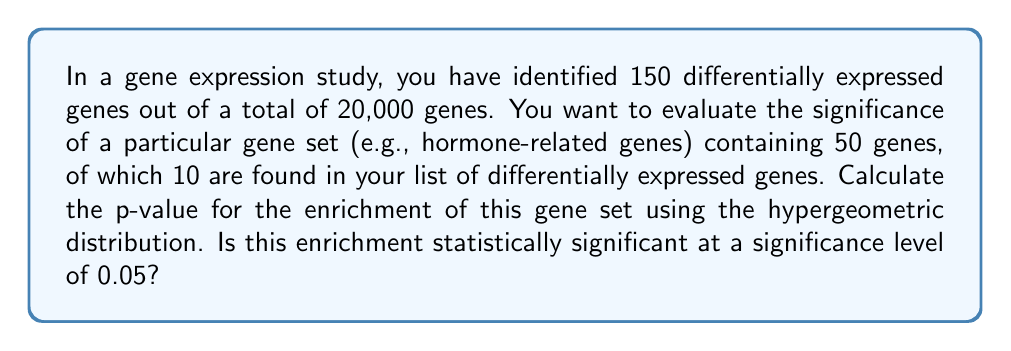Can you solve this math problem? To evaluate the significance of gene set enrichment using the hypergeometric distribution, we need to follow these steps:

1. Define the parameters:
   - $N$: Total number of genes = 20,000
   - $K$: Number of genes in the gene set of interest = 50
   - $n$: Number of differentially expressed genes = 150
   - $k$: Number of differentially expressed genes in the gene set = 10

2. The hypergeometric distribution calculates the probability of drawing $k$ successes from $n$ draws without replacement from a population of size $N$ containing $K$ successes.

3. The probability of observing exactly $k$ genes from the gene set in the differentially expressed list is given by:

   $$P(X = k) = \frac{\binom{K}{k} \binom{N-K}{n-k}}{\binom{N}{n}}$$

4. To calculate the p-value, we need to sum the probabilities of observing $k$ or more genes:

   $$p-value = P(X \geq k) = \sum_{i=k}^{\min(n,K)} \frac{\binom{K}{i} \binom{N-K}{n-i}}{\binom{N}{n}}$$

5. Using statistical software or a calculator with hypergeometric distribution functions, we can compute this p-value:

   $$p-value = 1.721 \times 10^{-5}$$

6. Compare the p-value to the significance level (α = 0.05):
   Since $1.721 \times 10^{-5} < 0.05$, we reject the null hypothesis of no enrichment.
Answer: The p-value for the enrichment of the gene set is $1.721 \times 10^{-5}$. This enrichment is statistically significant at the 0.05 level, as the p-value is less than 0.05. 